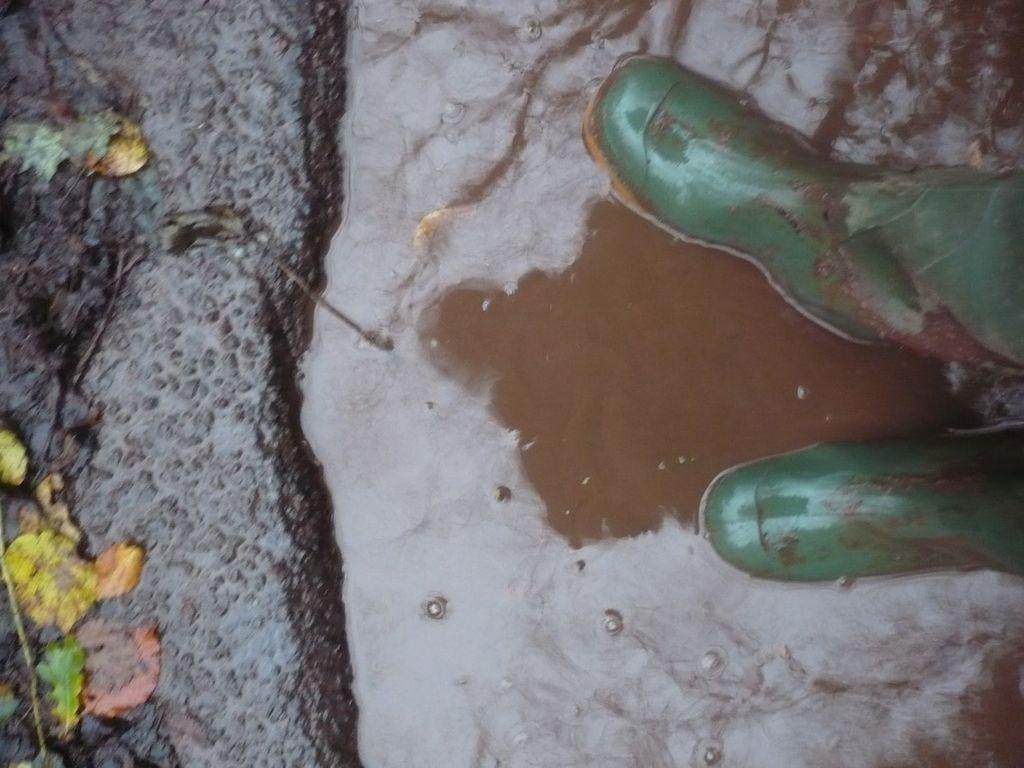What color are the boats in the image? The boats in the image are green. What is the primary element surrounding the boats? There is water visible in the image. What type of vegetation can be seen on the ground in the image? There are leaves on the ground in the image. Where is the kitty walking on the trail in the image? There is no kitty or trail present in the image. 